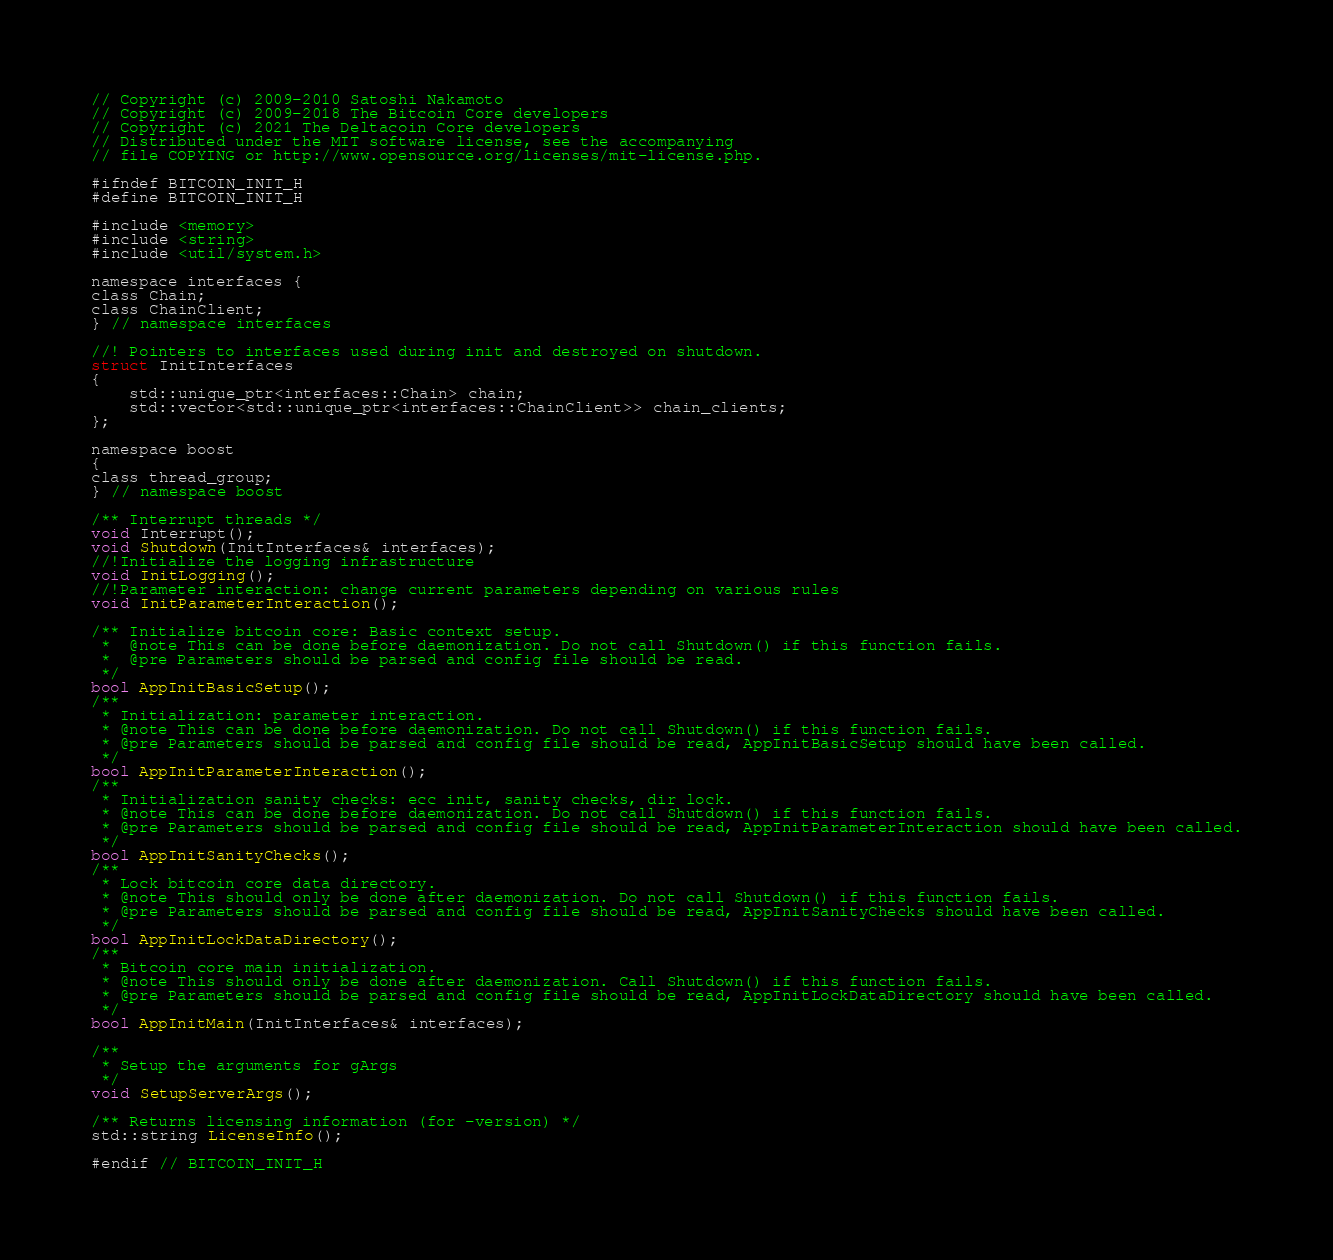Convert code to text. <code><loc_0><loc_0><loc_500><loc_500><_C_>// Copyright (c) 2009-2010 Satoshi Nakamoto
// Copyright (c) 2009-2018 The Bitcoin Core developers
// Copyright (c) 2021 The Deltacoin Core developers
// Distributed under the MIT software license, see the accompanying
// file COPYING or http://www.opensource.org/licenses/mit-license.php.

#ifndef BITCOIN_INIT_H
#define BITCOIN_INIT_H

#include <memory>
#include <string>
#include <util/system.h>

namespace interfaces {
class Chain;
class ChainClient;
} // namespace interfaces

//! Pointers to interfaces used during init and destroyed on shutdown.
struct InitInterfaces
{
    std::unique_ptr<interfaces::Chain> chain;
    std::vector<std::unique_ptr<interfaces::ChainClient>> chain_clients;
};

namespace boost
{
class thread_group;
} // namespace boost

/** Interrupt threads */
void Interrupt();
void Shutdown(InitInterfaces& interfaces);
//!Initialize the logging infrastructure
void InitLogging();
//!Parameter interaction: change current parameters depending on various rules
void InitParameterInteraction();

/** Initialize bitcoin core: Basic context setup.
 *  @note This can be done before daemonization. Do not call Shutdown() if this function fails.
 *  @pre Parameters should be parsed and config file should be read.
 */
bool AppInitBasicSetup();
/**
 * Initialization: parameter interaction.
 * @note This can be done before daemonization. Do not call Shutdown() if this function fails.
 * @pre Parameters should be parsed and config file should be read, AppInitBasicSetup should have been called.
 */
bool AppInitParameterInteraction();
/**
 * Initialization sanity checks: ecc init, sanity checks, dir lock.
 * @note This can be done before daemonization. Do not call Shutdown() if this function fails.
 * @pre Parameters should be parsed and config file should be read, AppInitParameterInteraction should have been called.
 */
bool AppInitSanityChecks();
/**
 * Lock bitcoin core data directory.
 * @note This should only be done after daemonization. Do not call Shutdown() if this function fails.
 * @pre Parameters should be parsed and config file should be read, AppInitSanityChecks should have been called.
 */
bool AppInitLockDataDirectory();
/**
 * Bitcoin core main initialization.
 * @note This should only be done after daemonization. Call Shutdown() if this function fails.
 * @pre Parameters should be parsed and config file should be read, AppInitLockDataDirectory should have been called.
 */
bool AppInitMain(InitInterfaces& interfaces);

/**
 * Setup the arguments for gArgs
 */
void SetupServerArgs();

/** Returns licensing information (for -version) */
std::string LicenseInfo();

#endif // BITCOIN_INIT_H
</code> 